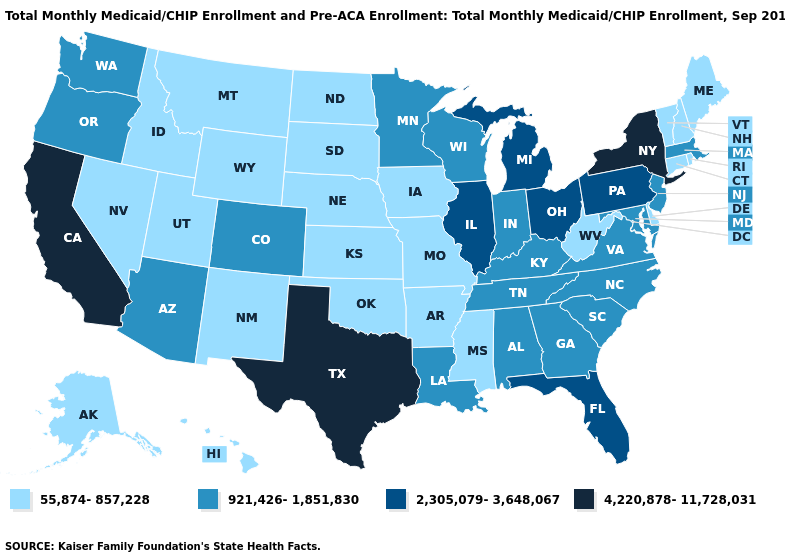Does the first symbol in the legend represent the smallest category?
Short answer required. Yes. What is the highest value in the USA?
Quick response, please. 4,220,878-11,728,031. What is the highest value in the West ?
Keep it brief. 4,220,878-11,728,031. Among the states that border Vermont , which have the lowest value?
Be succinct. New Hampshire. Among the states that border Kansas , which have the highest value?
Give a very brief answer. Colorado. Name the states that have a value in the range 55,874-857,228?
Answer briefly. Alaska, Arkansas, Connecticut, Delaware, Hawaii, Idaho, Iowa, Kansas, Maine, Mississippi, Missouri, Montana, Nebraska, Nevada, New Hampshire, New Mexico, North Dakota, Oklahoma, Rhode Island, South Dakota, Utah, Vermont, West Virginia, Wyoming. Name the states that have a value in the range 55,874-857,228?
Quick response, please. Alaska, Arkansas, Connecticut, Delaware, Hawaii, Idaho, Iowa, Kansas, Maine, Mississippi, Missouri, Montana, Nebraska, Nevada, New Hampshire, New Mexico, North Dakota, Oklahoma, Rhode Island, South Dakota, Utah, Vermont, West Virginia, Wyoming. What is the lowest value in the Northeast?
Give a very brief answer. 55,874-857,228. Name the states that have a value in the range 55,874-857,228?
Keep it brief. Alaska, Arkansas, Connecticut, Delaware, Hawaii, Idaho, Iowa, Kansas, Maine, Mississippi, Missouri, Montana, Nebraska, Nevada, New Hampshire, New Mexico, North Dakota, Oklahoma, Rhode Island, South Dakota, Utah, Vermont, West Virginia, Wyoming. How many symbols are there in the legend?
Quick response, please. 4. Among the states that border Texas , does Louisiana have the highest value?
Short answer required. Yes. What is the highest value in the West ?
Give a very brief answer. 4,220,878-11,728,031. What is the lowest value in states that border New York?
Give a very brief answer. 55,874-857,228. What is the value of Arkansas?
Concise answer only. 55,874-857,228. 